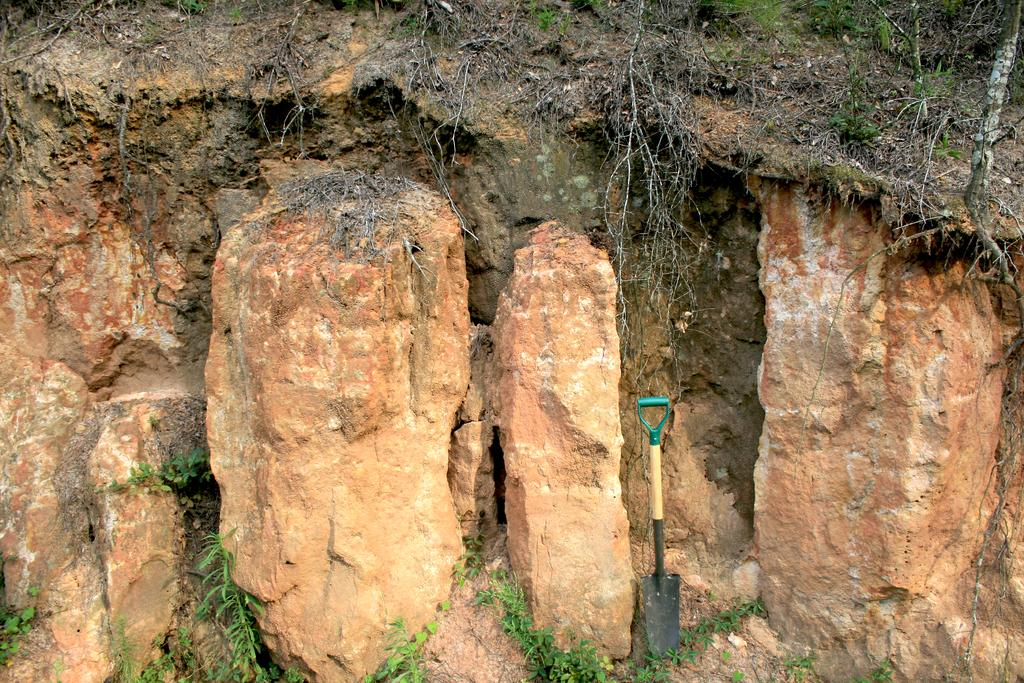What tool is visible in the image? There is a shovel in the image. What type of natural objects can be seen in the image? There are rocks in the image. What type of vegetation is present in the image? There are plants and grass in the image. What type of cork material can be seen in the image? There is no cork material present in the image. How does the loss of the shovel affect the image? The image does not depict any loss, and the shovel is present in the image. 